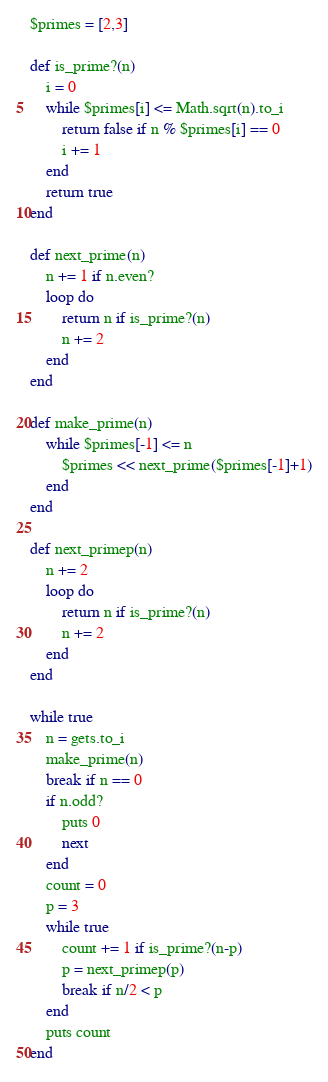<code> <loc_0><loc_0><loc_500><loc_500><_Ruby_>$primes = [2,3]

def is_prime?(n)
	i = 0
	while $primes[i] <= Math.sqrt(n).to_i
		return false if n % $primes[i] == 0
		i += 1
	end
	return true
end

def next_prime(n)
	n += 1 if n.even?
	loop do
		return n if is_prime?(n)
		n += 2
	end
end

def make_prime(n)
	while $primes[-1] <= n
		$primes << next_prime($primes[-1]+1)
	end
end

def next_primep(n)
	n += 2
	loop do
		return n if is_prime?(n)
		n += 2
	end
end

while true
	n = gets.to_i
	make_prime(n)
	break if n == 0
	if n.odd?
		puts 0
		next
	end
	count = 0
	p = 3
	while true
		count += 1 if is_prime?(n-p)
		p = next_primep(p)
		break if n/2 < p
	end
	puts count
end</code> 